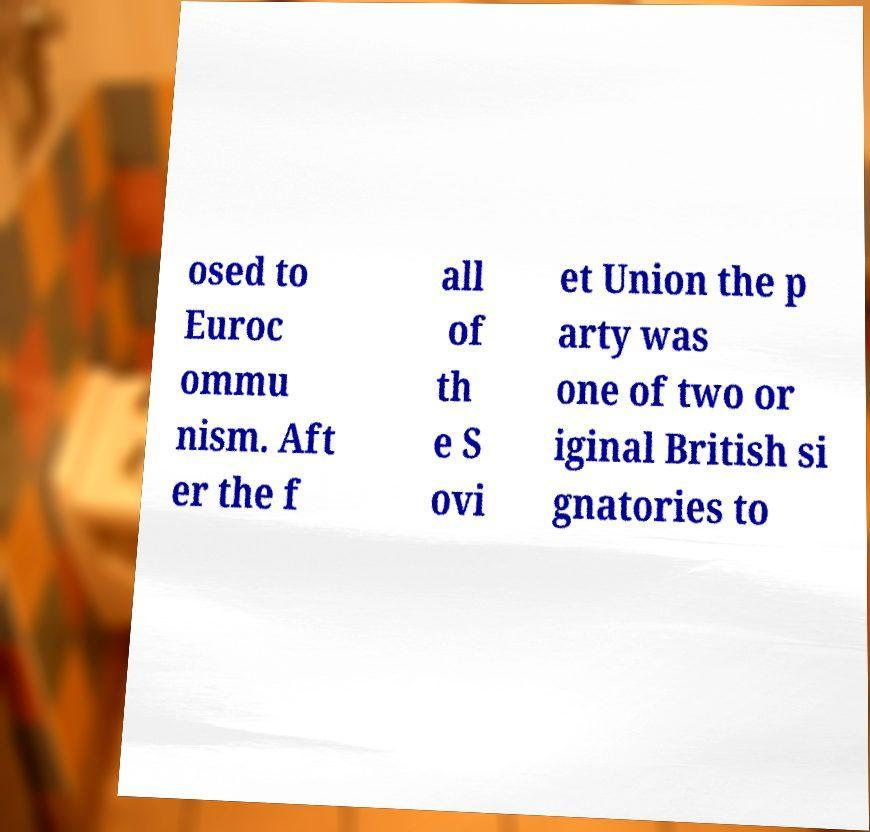There's text embedded in this image that I need extracted. Can you transcribe it verbatim? osed to Euroc ommu nism. Aft er the f all of th e S ovi et Union the p arty was one of two or iginal British si gnatories to 